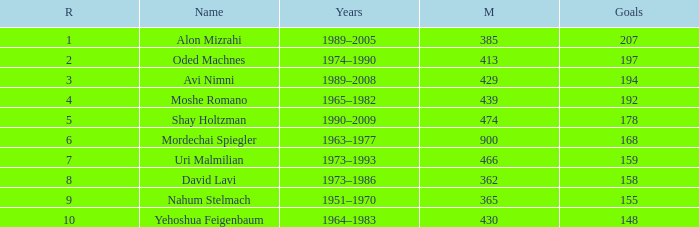What is the Rank of the player with 158 Goals in more than 362 Matches? 0.0. 